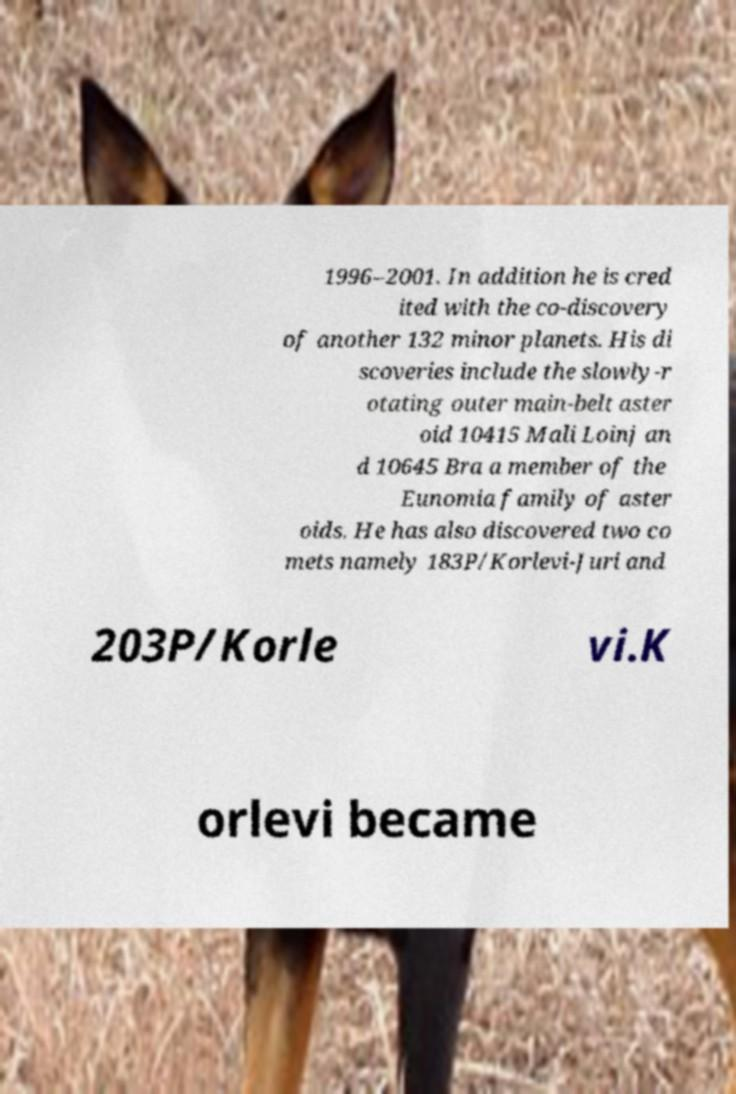Could you extract and type out the text from this image? 1996–2001. In addition he is cred ited with the co-discovery of another 132 minor planets. His di scoveries include the slowly-r otating outer main-belt aster oid 10415 Mali Loinj an d 10645 Bra a member of the Eunomia family of aster oids. He has also discovered two co mets namely 183P/Korlevi-Juri and 203P/Korle vi.K orlevi became 